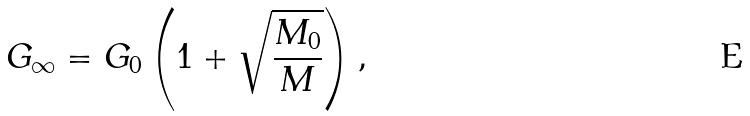Convert formula to latex. <formula><loc_0><loc_0><loc_500><loc_500>G _ { \infty } = G _ { 0 } \left ( 1 + \sqrt { \frac { M _ { 0 } } { M } } \right ) ,</formula> 